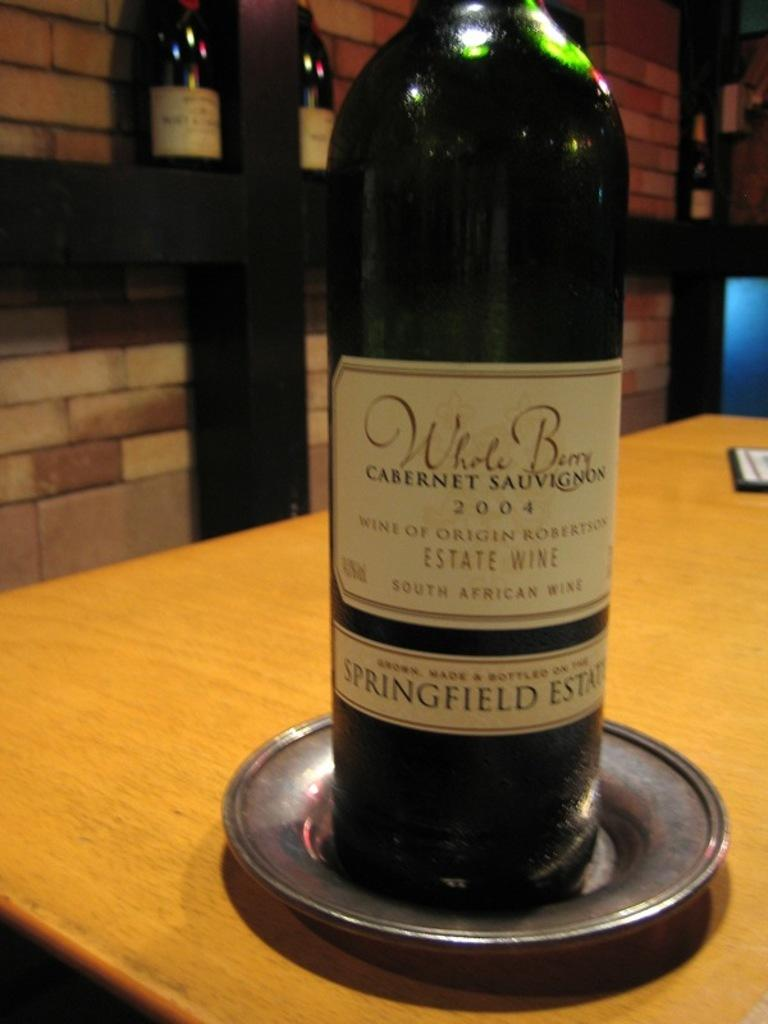<image>
Relay a brief, clear account of the picture shown. the word cabernet that is on a wine bottle 